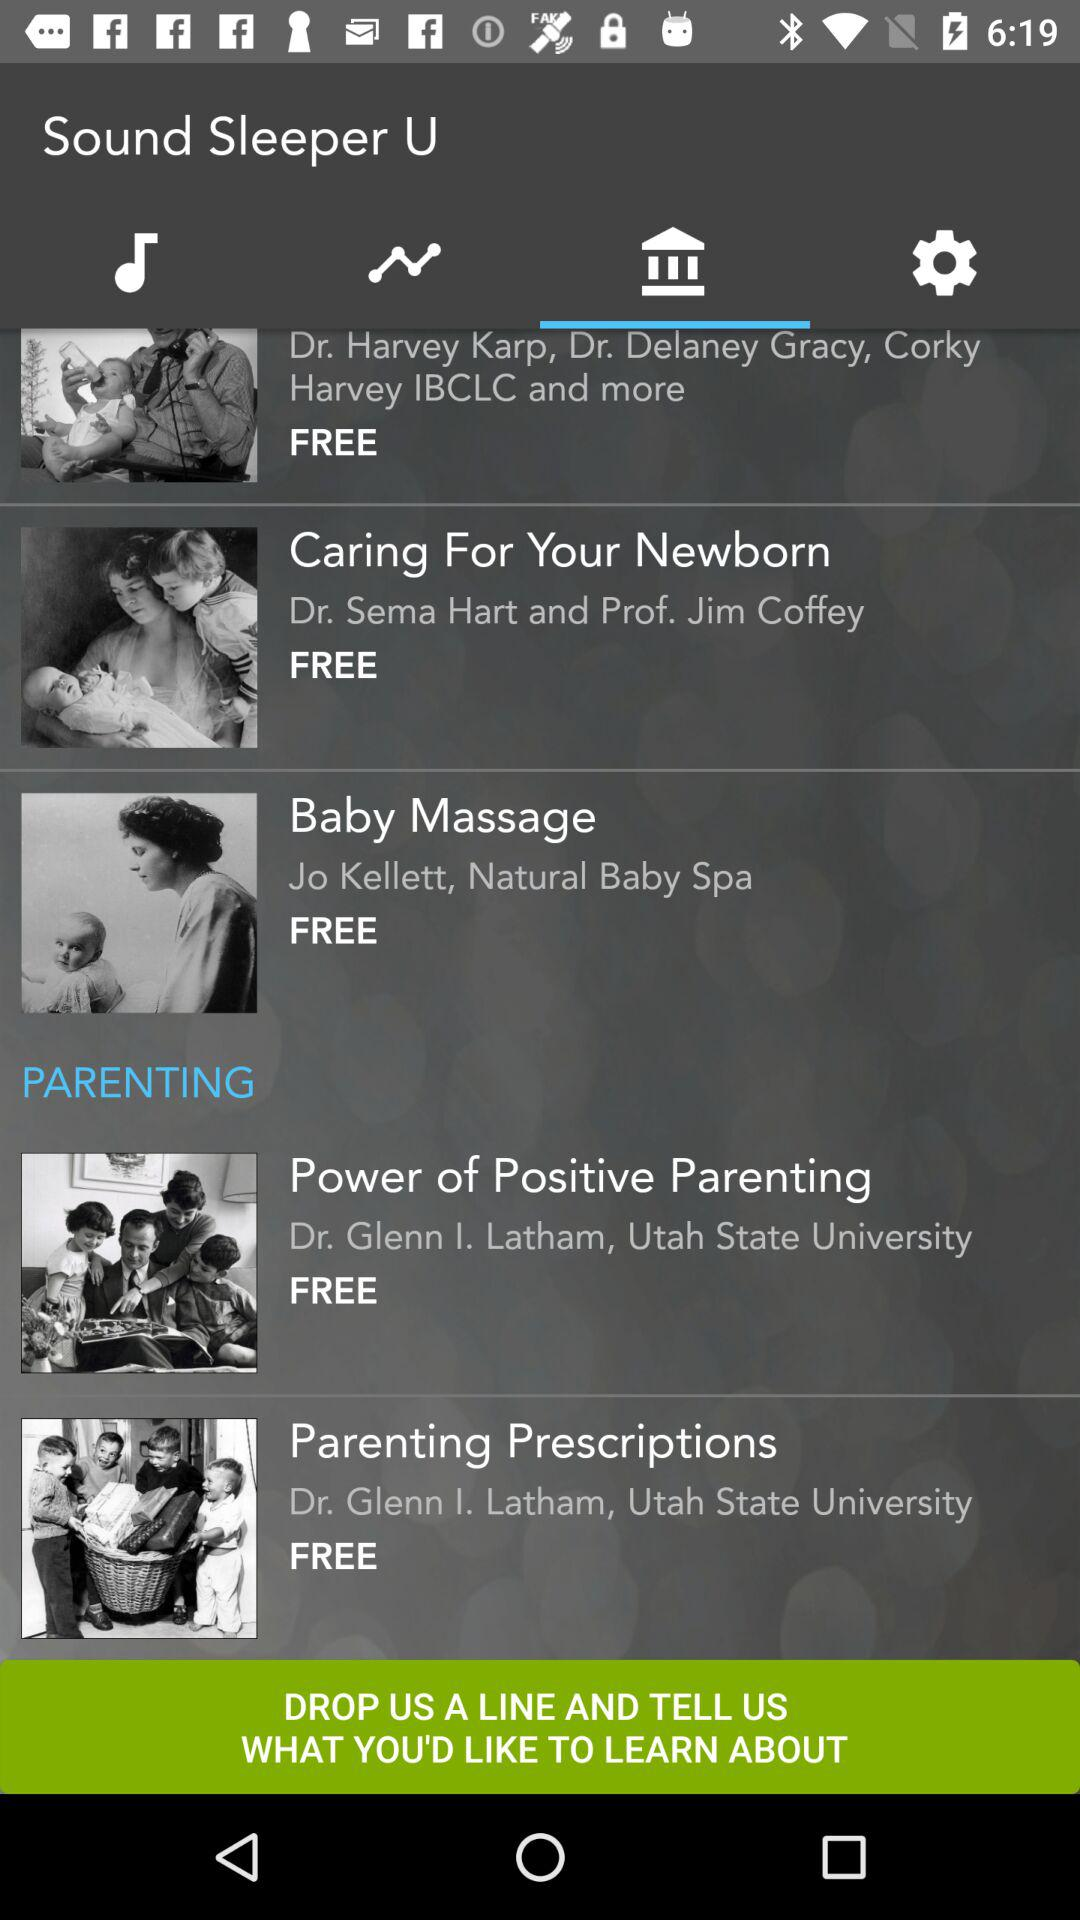Who is the author of "Baby Massage"? The author is Jo Kellett. 